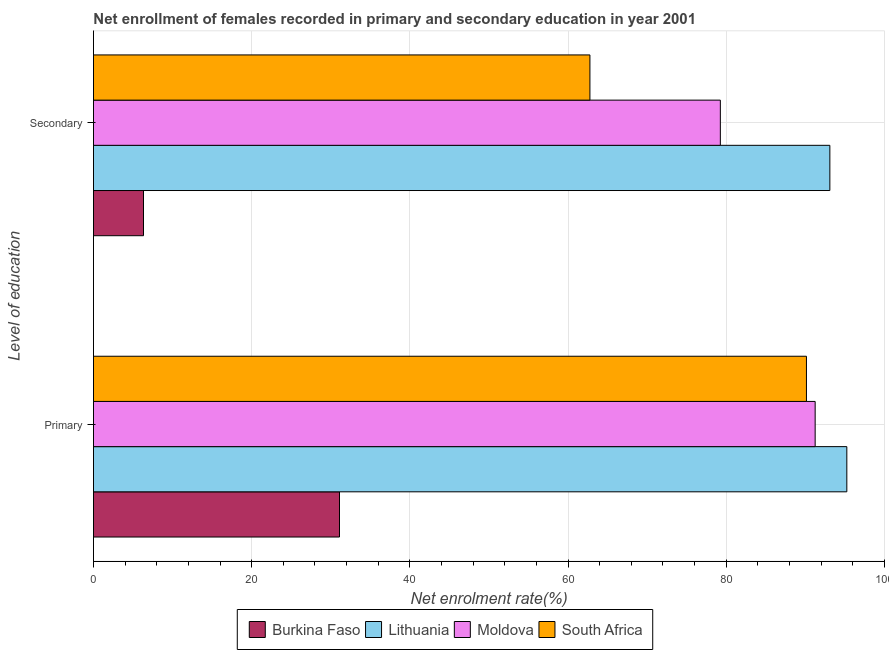How many different coloured bars are there?
Provide a succinct answer. 4. How many groups of bars are there?
Your answer should be very brief. 2. Are the number of bars per tick equal to the number of legend labels?
Make the answer very short. Yes. Are the number of bars on each tick of the Y-axis equal?
Provide a short and direct response. Yes. How many bars are there on the 2nd tick from the top?
Ensure brevity in your answer.  4. What is the label of the 2nd group of bars from the top?
Make the answer very short. Primary. What is the enrollment rate in primary education in Burkina Faso?
Keep it short and to the point. 31.11. Across all countries, what is the maximum enrollment rate in primary education?
Your answer should be compact. 95.25. Across all countries, what is the minimum enrollment rate in secondary education?
Make the answer very short. 6.33. In which country was the enrollment rate in primary education maximum?
Your response must be concise. Lithuania. In which country was the enrollment rate in primary education minimum?
Offer a terse response. Burkina Faso. What is the total enrollment rate in primary education in the graph?
Your answer should be compact. 307.76. What is the difference between the enrollment rate in secondary education in Moldova and that in Lithuania?
Offer a very short reply. -13.85. What is the difference between the enrollment rate in primary education in South Africa and the enrollment rate in secondary education in Burkina Faso?
Provide a succinct answer. 83.82. What is the average enrollment rate in primary education per country?
Offer a terse response. 76.94. What is the difference between the enrollment rate in primary education and enrollment rate in secondary education in Burkina Faso?
Provide a succinct answer. 24.78. What is the ratio of the enrollment rate in secondary education in Lithuania to that in Burkina Faso?
Provide a succinct answer. 14.72. Is the enrollment rate in secondary education in Lithuania less than that in Burkina Faso?
Your response must be concise. No. What does the 4th bar from the top in Secondary represents?
Make the answer very short. Burkina Faso. What does the 1st bar from the bottom in Primary represents?
Keep it short and to the point. Burkina Faso. How many bars are there?
Provide a short and direct response. 8. How many countries are there in the graph?
Offer a terse response. 4. What is the difference between two consecutive major ticks on the X-axis?
Provide a short and direct response. 20. Does the graph contain any zero values?
Give a very brief answer. No. Does the graph contain grids?
Your answer should be very brief. Yes. How many legend labels are there?
Your response must be concise. 4. How are the legend labels stacked?
Offer a very short reply. Horizontal. What is the title of the graph?
Ensure brevity in your answer.  Net enrollment of females recorded in primary and secondary education in year 2001. Does "Korea (Republic)" appear as one of the legend labels in the graph?
Offer a terse response. No. What is the label or title of the X-axis?
Offer a terse response. Net enrolment rate(%). What is the label or title of the Y-axis?
Your answer should be very brief. Level of education. What is the Net enrolment rate(%) of Burkina Faso in Primary?
Provide a short and direct response. 31.11. What is the Net enrolment rate(%) in Lithuania in Primary?
Provide a short and direct response. 95.25. What is the Net enrolment rate(%) in Moldova in Primary?
Provide a short and direct response. 91.25. What is the Net enrolment rate(%) in South Africa in Primary?
Provide a short and direct response. 90.15. What is the Net enrolment rate(%) in Burkina Faso in Secondary?
Provide a short and direct response. 6.33. What is the Net enrolment rate(%) in Lithuania in Secondary?
Make the answer very short. 93.11. What is the Net enrolment rate(%) of Moldova in Secondary?
Give a very brief answer. 79.26. What is the Net enrolment rate(%) in South Africa in Secondary?
Provide a succinct answer. 62.77. Across all Level of education, what is the maximum Net enrolment rate(%) of Burkina Faso?
Your answer should be very brief. 31.11. Across all Level of education, what is the maximum Net enrolment rate(%) in Lithuania?
Offer a terse response. 95.25. Across all Level of education, what is the maximum Net enrolment rate(%) of Moldova?
Offer a very short reply. 91.25. Across all Level of education, what is the maximum Net enrolment rate(%) in South Africa?
Provide a short and direct response. 90.15. Across all Level of education, what is the minimum Net enrolment rate(%) of Burkina Faso?
Ensure brevity in your answer.  6.33. Across all Level of education, what is the minimum Net enrolment rate(%) in Lithuania?
Provide a succinct answer. 93.11. Across all Level of education, what is the minimum Net enrolment rate(%) of Moldova?
Offer a terse response. 79.26. Across all Level of education, what is the minimum Net enrolment rate(%) in South Africa?
Offer a very short reply. 62.77. What is the total Net enrolment rate(%) of Burkina Faso in the graph?
Your answer should be very brief. 37.43. What is the total Net enrolment rate(%) of Lithuania in the graph?
Provide a short and direct response. 188.36. What is the total Net enrolment rate(%) of Moldova in the graph?
Your answer should be very brief. 170.51. What is the total Net enrolment rate(%) in South Africa in the graph?
Your answer should be very brief. 152.92. What is the difference between the Net enrolment rate(%) in Burkina Faso in Primary and that in Secondary?
Offer a terse response. 24.78. What is the difference between the Net enrolment rate(%) of Lithuania in Primary and that in Secondary?
Ensure brevity in your answer.  2.14. What is the difference between the Net enrolment rate(%) of Moldova in Primary and that in Secondary?
Offer a terse response. 11.99. What is the difference between the Net enrolment rate(%) of South Africa in Primary and that in Secondary?
Provide a short and direct response. 27.38. What is the difference between the Net enrolment rate(%) in Burkina Faso in Primary and the Net enrolment rate(%) in Lithuania in Secondary?
Ensure brevity in your answer.  -62. What is the difference between the Net enrolment rate(%) of Burkina Faso in Primary and the Net enrolment rate(%) of Moldova in Secondary?
Your response must be concise. -48.15. What is the difference between the Net enrolment rate(%) in Burkina Faso in Primary and the Net enrolment rate(%) in South Africa in Secondary?
Offer a very short reply. -31.66. What is the difference between the Net enrolment rate(%) in Lithuania in Primary and the Net enrolment rate(%) in Moldova in Secondary?
Your answer should be very brief. 15.99. What is the difference between the Net enrolment rate(%) in Lithuania in Primary and the Net enrolment rate(%) in South Africa in Secondary?
Provide a succinct answer. 32.48. What is the difference between the Net enrolment rate(%) in Moldova in Primary and the Net enrolment rate(%) in South Africa in Secondary?
Keep it short and to the point. 28.48. What is the average Net enrolment rate(%) in Burkina Faso per Level of education?
Your answer should be very brief. 18.72. What is the average Net enrolment rate(%) in Lithuania per Level of education?
Offer a very short reply. 94.18. What is the average Net enrolment rate(%) of Moldova per Level of education?
Keep it short and to the point. 85.25. What is the average Net enrolment rate(%) in South Africa per Level of education?
Offer a terse response. 76.46. What is the difference between the Net enrolment rate(%) in Burkina Faso and Net enrolment rate(%) in Lithuania in Primary?
Ensure brevity in your answer.  -64.14. What is the difference between the Net enrolment rate(%) of Burkina Faso and Net enrolment rate(%) of Moldova in Primary?
Provide a succinct answer. -60.14. What is the difference between the Net enrolment rate(%) in Burkina Faso and Net enrolment rate(%) in South Africa in Primary?
Your answer should be very brief. -59.04. What is the difference between the Net enrolment rate(%) in Lithuania and Net enrolment rate(%) in Moldova in Primary?
Keep it short and to the point. 4. What is the difference between the Net enrolment rate(%) of Lithuania and Net enrolment rate(%) of South Africa in Primary?
Ensure brevity in your answer.  5.1. What is the difference between the Net enrolment rate(%) of Moldova and Net enrolment rate(%) of South Africa in Primary?
Keep it short and to the point. 1.1. What is the difference between the Net enrolment rate(%) in Burkina Faso and Net enrolment rate(%) in Lithuania in Secondary?
Offer a terse response. -86.78. What is the difference between the Net enrolment rate(%) of Burkina Faso and Net enrolment rate(%) of Moldova in Secondary?
Make the answer very short. -72.93. What is the difference between the Net enrolment rate(%) in Burkina Faso and Net enrolment rate(%) in South Africa in Secondary?
Your response must be concise. -56.44. What is the difference between the Net enrolment rate(%) of Lithuania and Net enrolment rate(%) of Moldova in Secondary?
Your answer should be very brief. 13.85. What is the difference between the Net enrolment rate(%) of Lithuania and Net enrolment rate(%) of South Africa in Secondary?
Your answer should be very brief. 30.34. What is the difference between the Net enrolment rate(%) in Moldova and Net enrolment rate(%) in South Africa in Secondary?
Make the answer very short. 16.49. What is the ratio of the Net enrolment rate(%) of Burkina Faso in Primary to that in Secondary?
Provide a short and direct response. 4.92. What is the ratio of the Net enrolment rate(%) in Lithuania in Primary to that in Secondary?
Keep it short and to the point. 1.02. What is the ratio of the Net enrolment rate(%) of Moldova in Primary to that in Secondary?
Provide a succinct answer. 1.15. What is the ratio of the Net enrolment rate(%) of South Africa in Primary to that in Secondary?
Your answer should be compact. 1.44. What is the difference between the highest and the second highest Net enrolment rate(%) in Burkina Faso?
Provide a succinct answer. 24.78. What is the difference between the highest and the second highest Net enrolment rate(%) in Lithuania?
Offer a very short reply. 2.14. What is the difference between the highest and the second highest Net enrolment rate(%) in Moldova?
Your answer should be very brief. 11.99. What is the difference between the highest and the second highest Net enrolment rate(%) in South Africa?
Your response must be concise. 27.38. What is the difference between the highest and the lowest Net enrolment rate(%) of Burkina Faso?
Offer a terse response. 24.78. What is the difference between the highest and the lowest Net enrolment rate(%) of Lithuania?
Your answer should be very brief. 2.14. What is the difference between the highest and the lowest Net enrolment rate(%) in Moldova?
Keep it short and to the point. 11.99. What is the difference between the highest and the lowest Net enrolment rate(%) in South Africa?
Provide a succinct answer. 27.38. 